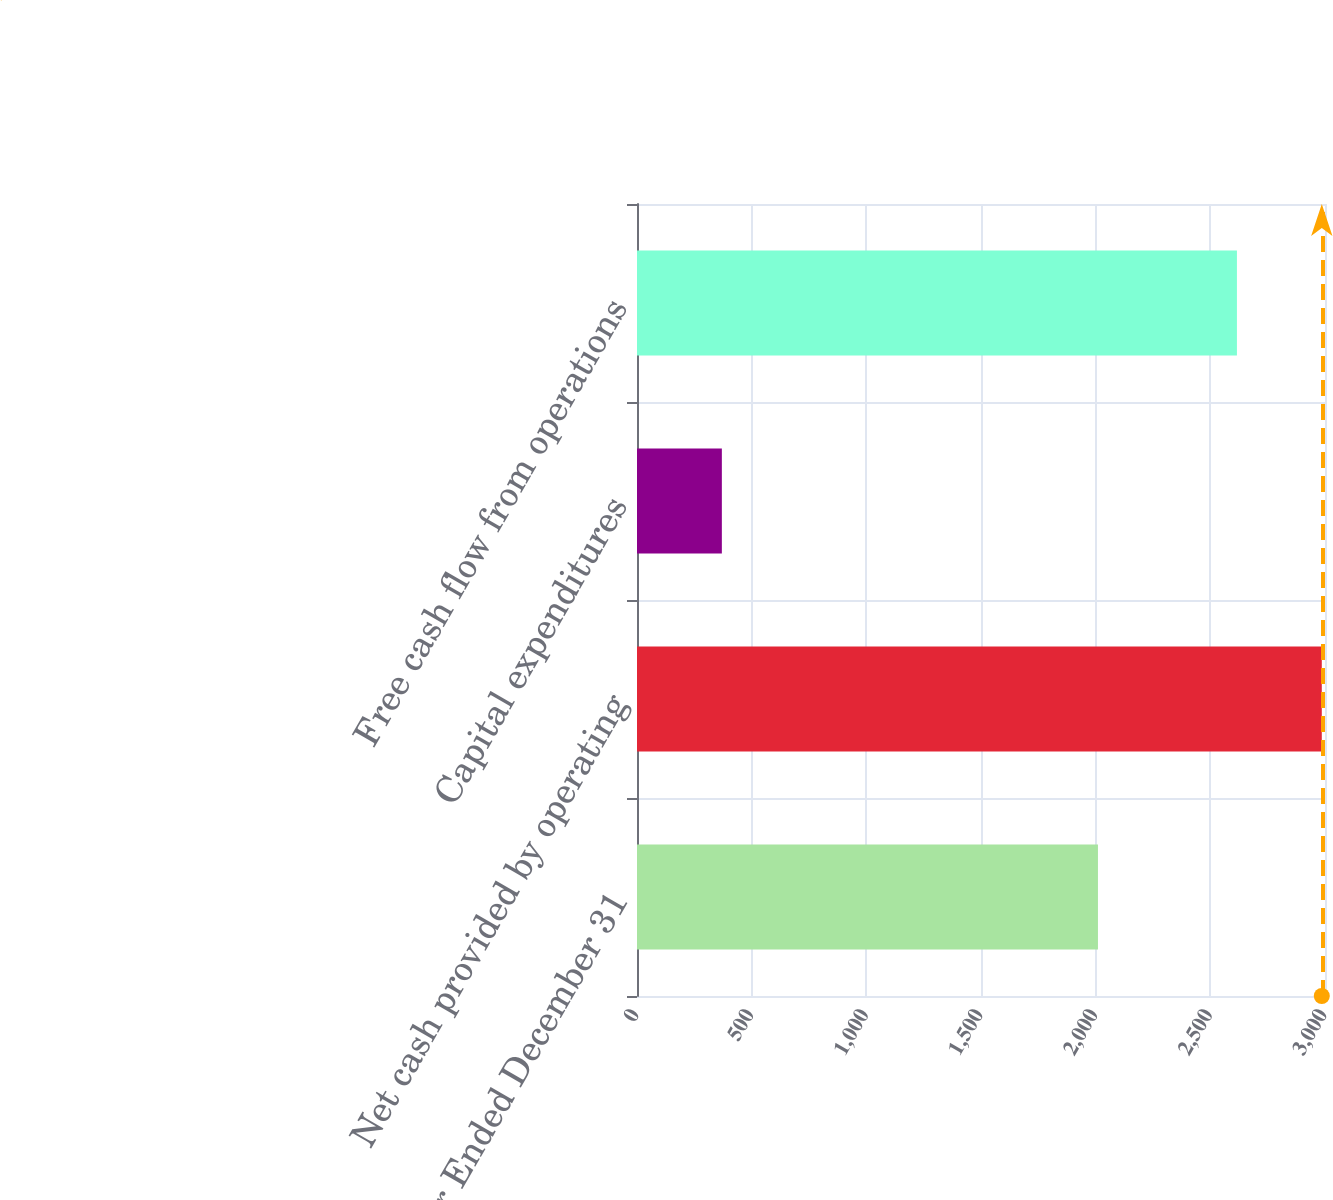Convert chart. <chart><loc_0><loc_0><loc_500><loc_500><bar_chart><fcel>Year Ended December 31<fcel>Net cash provided by operating<fcel>Capital expenditures<fcel>Free cash flow from operations<nl><fcel>2010<fcel>2986<fcel>370<fcel>2616<nl></chart> 